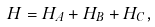Convert formula to latex. <formula><loc_0><loc_0><loc_500><loc_500>H = H _ { A } + H _ { B } + H _ { C } ,</formula> 